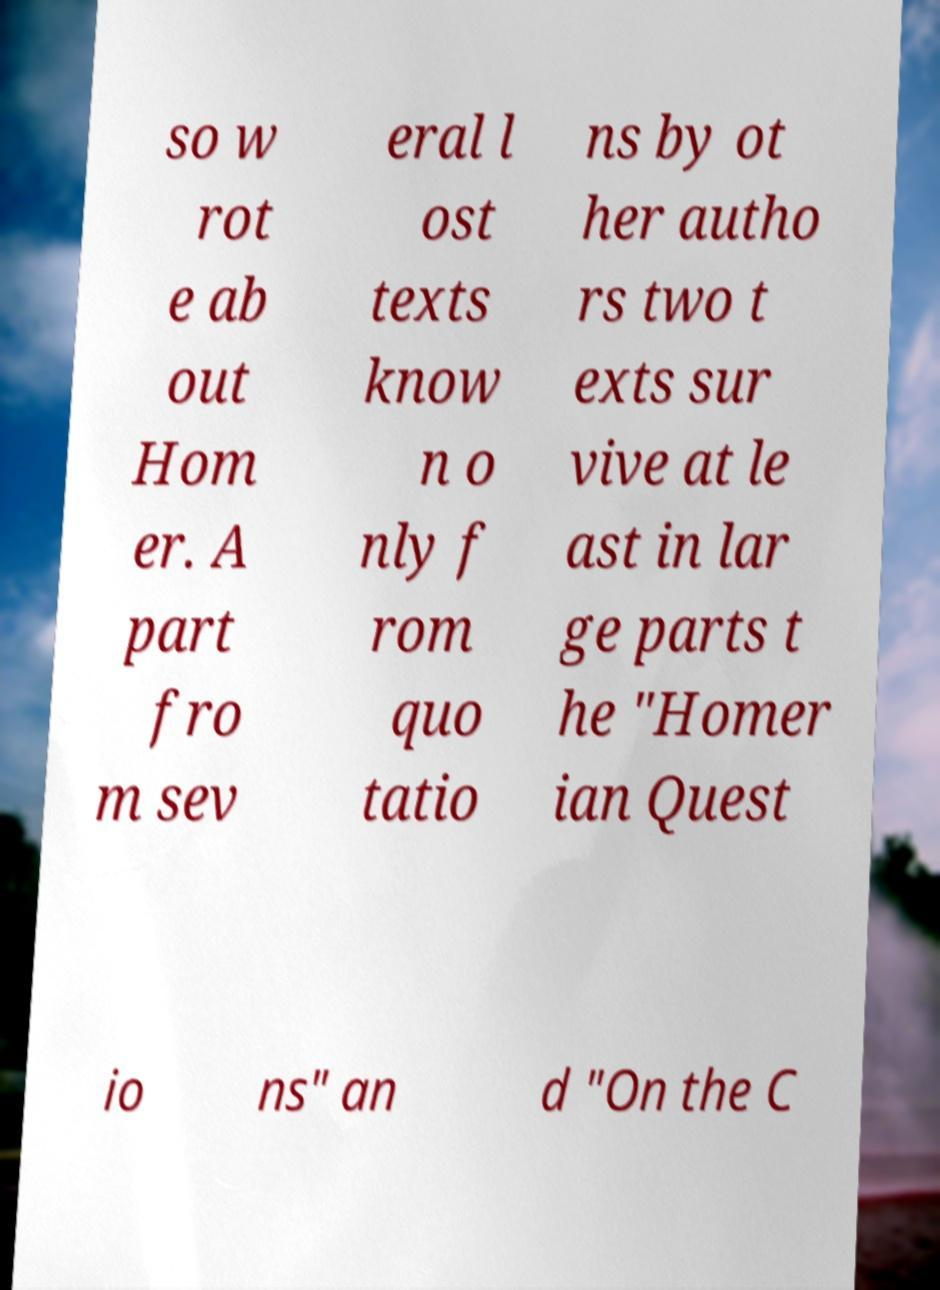Please read and relay the text visible in this image. What does it say? so w rot e ab out Hom er. A part fro m sev eral l ost texts know n o nly f rom quo tatio ns by ot her autho rs two t exts sur vive at le ast in lar ge parts t he "Homer ian Quest io ns" an d "On the C 